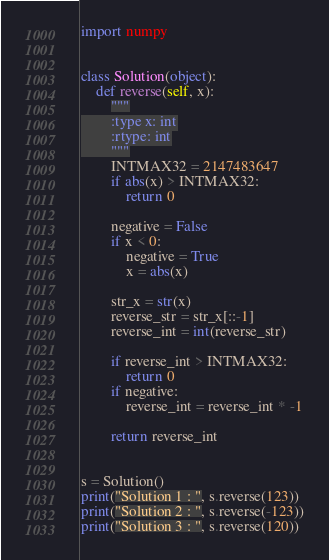<code> <loc_0><loc_0><loc_500><loc_500><_Python_>import numpy


class Solution(object):
    def reverse(self, x):
        """
        :type x: int
        :rtype: int
        """
        INTMAX32 = 2147483647
        if abs(x) > INTMAX32:
            return 0

        negative = False
        if x < 0:
            negative = True
            x = abs(x)

        str_x = str(x)
        reverse_str = str_x[::-1]
        reverse_int = int(reverse_str)

        if reverse_int > INTMAX32:
            return 0
        if negative:
            reverse_int = reverse_int * -1

        return reverse_int


s = Solution()
print("Solution 1 : ", s.reverse(123))
print("Solution 2 : ", s.reverse(-123))
print("Solution 3 : ", s.reverse(120))
</code> 